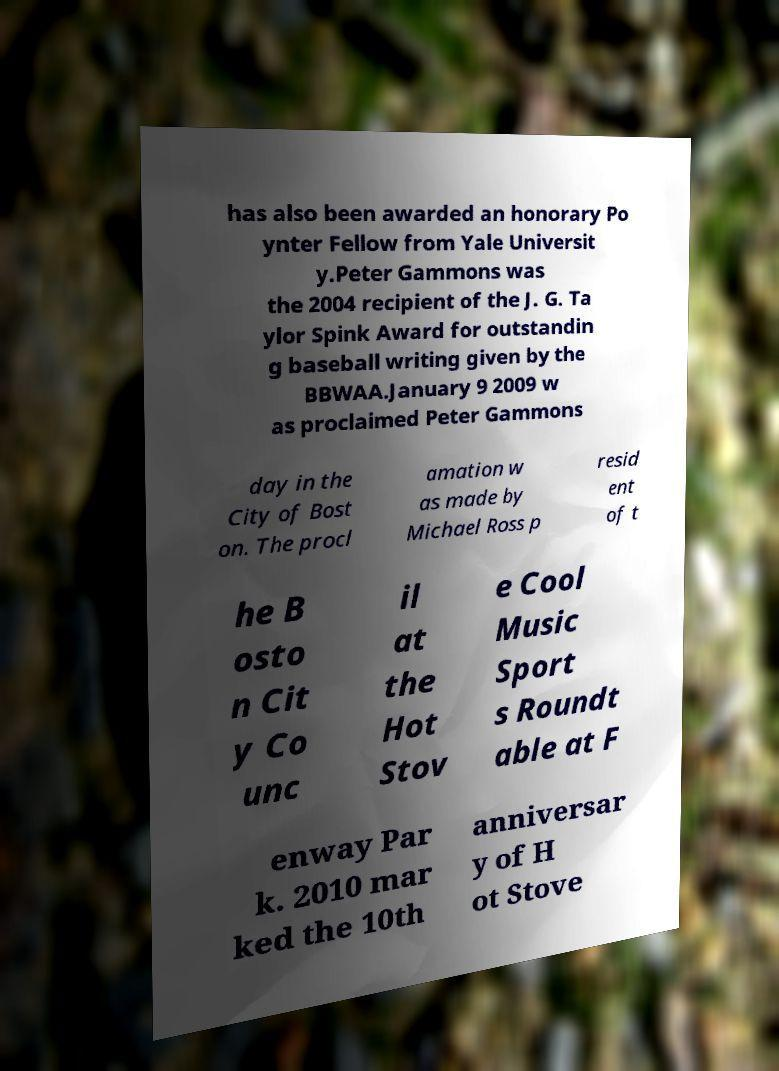Can you read and provide the text displayed in the image?This photo seems to have some interesting text. Can you extract and type it out for me? has also been awarded an honorary Po ynter Fellow from Yale Universit y.Peter Gammons was the 2004 recipient of the J. G. Ta ylor Spink Award for outstandin g baseball writing given by the BBWAA.January 9 2009 w as proclaimed Peter Gammons day in the City of Bost on. The procl amation w as made by Michael Ross p resid ent of t he B osto n Cit y Co unc il at the Hot Stov e Cool Music Sport s Roundt able at F enway Par k. 2010 mar ked the 10th anniversar y of H ot Stove 